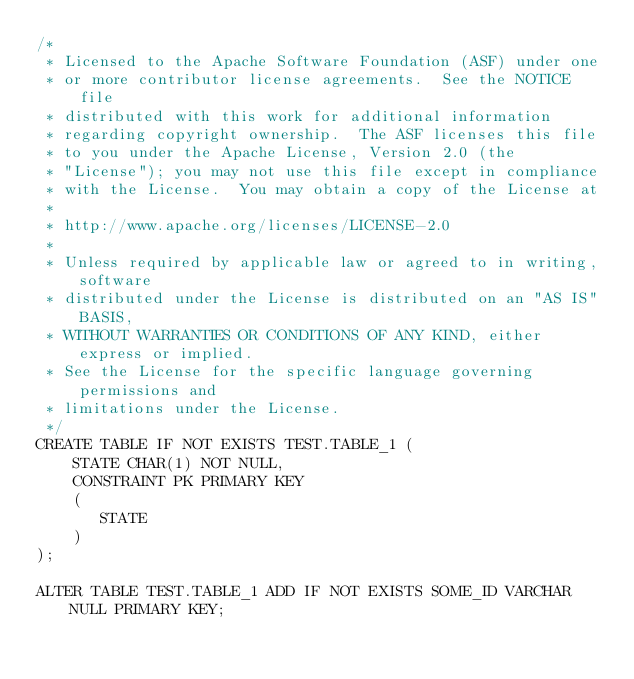<code> <loc_0><loc_0><loc_500><loc_500><_SQL_>/*
 * Licensed to the Apache Software Foundation (ASF) under one
 * or more contributor license agreements.  See the NOTICE file
 * distributed with this work for additional information
 * regarding copyright ownership.  The ASF licenses this file
 * to you under the Apache License, Version 2.0 (the
 * "License"); you may not use this file except in compliance
 * with the License.  You may obtain a copy of the License at
 *
 * http://www.apache.org/licenses/LICENSE-2.0
 *
 * Unless required by applicable law or agreed to in writing, software
 * distributed under the License is distributed on an "AS IS" BASIS,
 * WITHOUT WARRANTIES OR CONDITIONS OF ANY KIND, either express or implied.
 * See the License for the specific language governing permissions and
 * limitations under the License.
 */
CREATE TABLE IF NOT EXISTS TEST.TABLE_1 (
	STATE CHAR(1) NOT NULL,
	CONSTRAINT PK PRIMARY KEY
    (
       STATE
    )
);

ALTER TABLE TEST.TABLE_1 ADD IF NOT EXISTS SOME_ID VARCHAR NULL PRIMARY KEY;</code> 